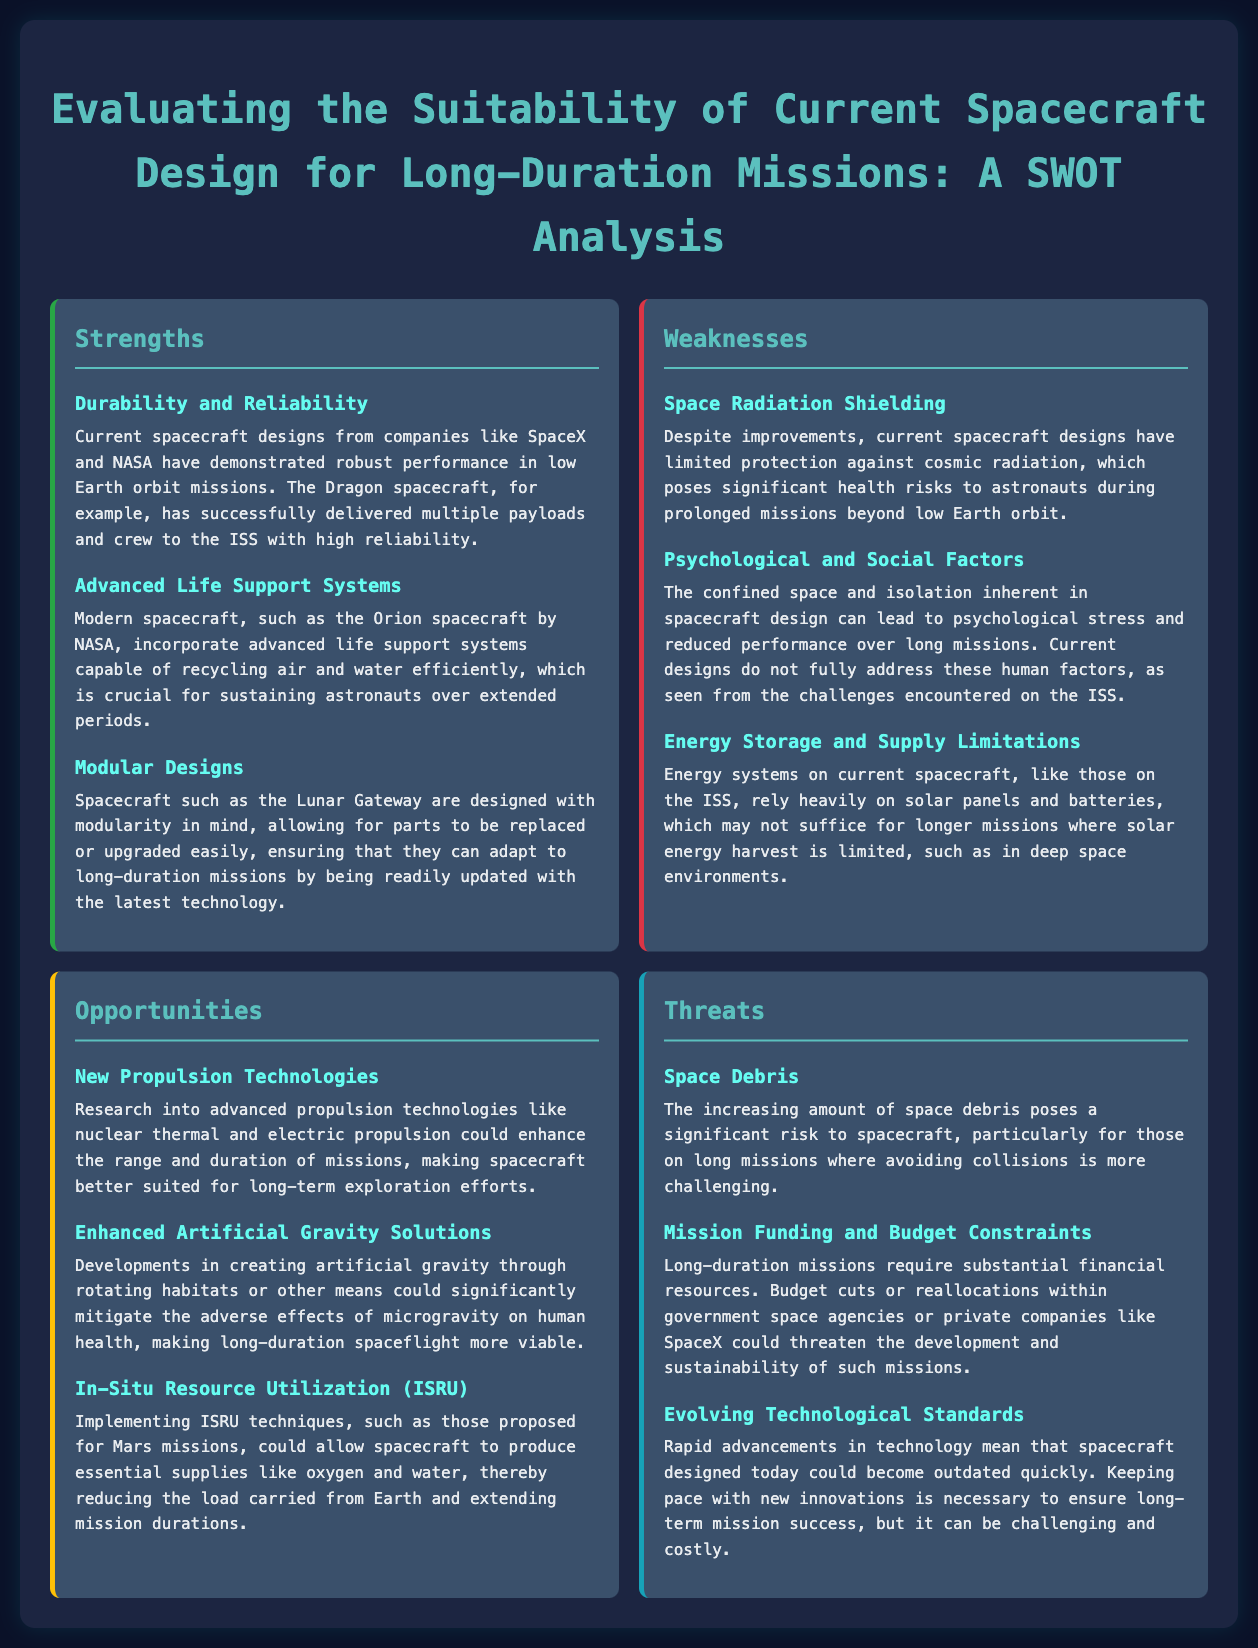What is one strength of current spacecraft designs? The document lists several strengths, one of which is that current spacecraft designs from companies like SpaceX and NASA have demonstrated robust performance in low Earth orbit missions.
Answer: Durability and Reliability What is a weakness related to energy systems on current spacecraft? The document specifies that energy systems on current spacecraft rely heavily on solar panels and batteries, which may not suffice for longer missions.
Answer: Energy Storage and Supply Limitations What opportunity involves improving mission duration? The document discusses advanced propulsion technologies that could enhance the range and duration of missions.
Answer: New Propulsion Technologies What is a threat posed by the increasing amount of space debris? The document states that space debris poses a significant risk to spacecraft, particularly for those on long missions.
Answer: Space Debris Which spacecraft design incorporates advanced life support systems? The document mentions the Orion spacecraft by NASA as an example of modern spacecraft that incorporates advanced life support systems.
Answer: Orion spacecraft What are psychological and social factors considered a weakness in current designs? The document notes that the confined space and isolation in spacecraft design can lead to psychological stress and reduced performance.
Answer: Psychological and Social Factors What does ISRU stand for in the context of long-duration missions? The document explains ISRU as In-Situ Resource Utilization, which could allow spacecraft to produce essential supplies like oxygen and water.
Answer: In-Situ Resource Utilization Which aspect of spacecraft designs needs improvement due to rapid advancements? The document indicates that keeping pace with new innovations is necessary for long-term mission success.
Answer: Evolving Technological Standards 